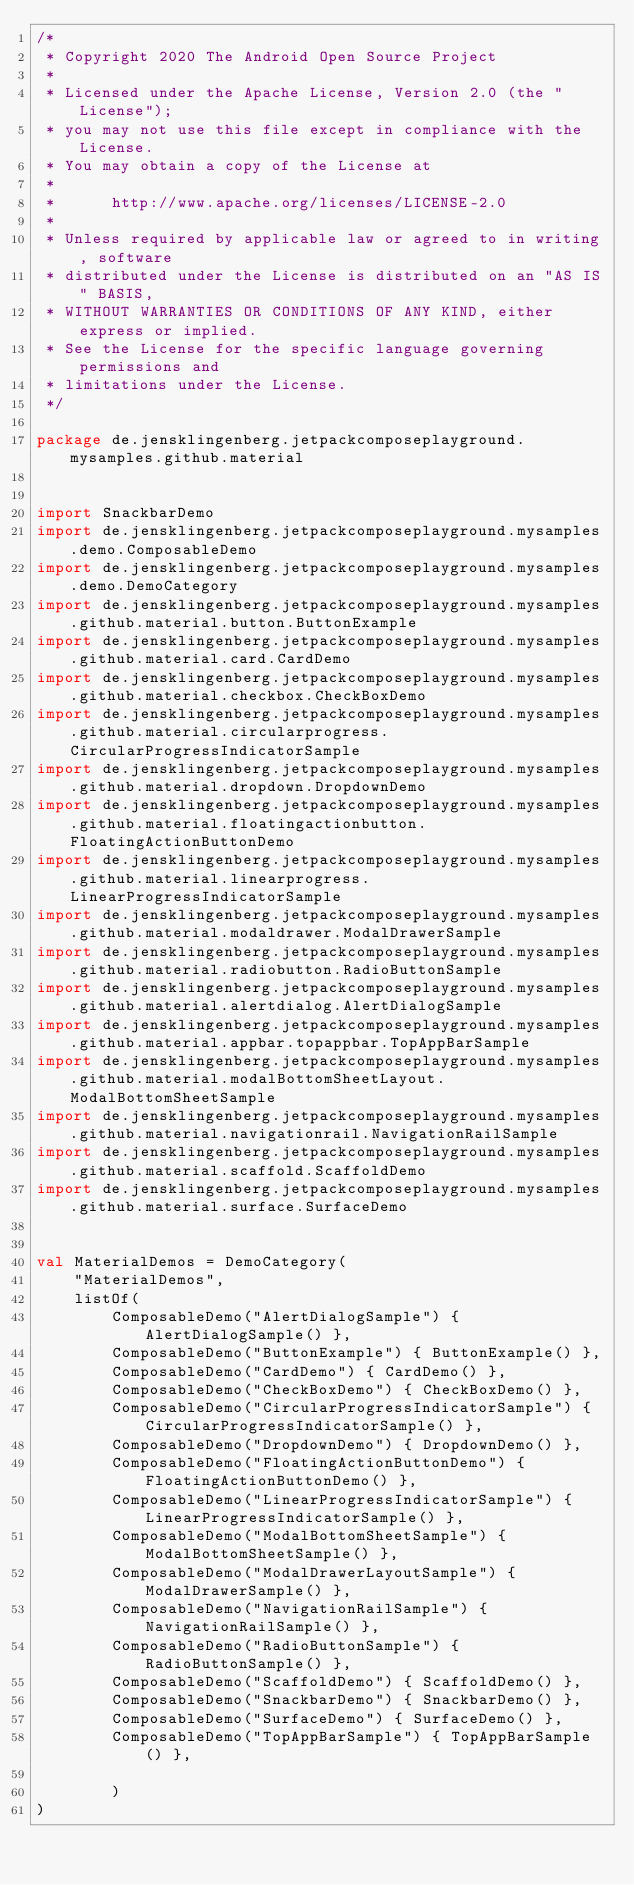<code> <loc_0><loc_0><loc_500><loc_500><_Kotlin_>/*
 * Copyright 2020 The Android Open Source Project
 *
 * Licensed under the Apache License, Version 2.0 (the "License");
 * you may not use this file except in compliance with the License.
 * You may obtain a copy of the License at
 *
 *      http://www.apache.org/licenses/LICENSE-2.0
 *
 * Unless required by applicable law or agreed to in writing, software
 * distributed under the License is distributed on an "AS IS" BASIS,
 * WITHOUT WARRANTIES OR CONDITIONS OF ANY KIND, either express or implied.
 * See the License for the specific language governing permissions and
 * limitations under the License.
 */

package de.jensklingenberg.jetpackcomposeplayground.mysamples.github.material


import SnackbarDemo
import de.jensklingenberg.jetpackcomposeplayground.mysamples.demo.ComposableDemo
import de.jensklingenberg.jetpackcomposeplayground.mysamples.demo.DemoCategory
import de.jensklingenberg.jetpackcomposeplayground.mysamples.github.material.button.ButtonExample
import de.jensklingenberg.jetpackcomposeplayground.mysamples.github.material.card.CardDemo
import de.jensklingenberg.jetpackcomposeplayground.mysamples.github.material.checkbox.CheckBoxDemo
import de.jensklingenberg.jetpackcomposeplayground.mysamples.github.material.circularprogress.CircularProgressIndicatorSample
import de.jensklingenberg.jetpackcomposeplayground.mysamples.github.material.dropdown.DropdownDemo
import de.jensklingenberg.jetpackcomposeplayground.mysamples.github.material.floatingactionbutton.FloatingActionButtonDemo
import de.jensklingenberg.jetpackcomposeplayground.mysamples.github.material.linearprogress.LinearProgressIndicatorSample
import de.jensklingenberg.jetpackcomposeplayground.mysamples.github.material.modaldrawer.ModalDrawerSample
import de.jensklingenberg.jetpackcomposeplayground.mysamples.github.material.radiobutton.RadioButtonSample
import de.jensklingenberg.jetpackcomposeplayground.mysamples.github.material.alertdialog.AlertDialogSample
import de.jensklingenberg.jetpackcomposeplayground.mysamples.github.material.appbar.topappbar.TopAppBarSample
import de.jensklingenberg.jetpackcomposeplayground.mysamples.github.material.modalBottomSheetLayout.ModalBottomSheetSample
import de.jensklingenberg.jetpackcomposeplayground.mysamples.github.material.navigationrail.NavigationRailSample
import de.jensklingenberg.jetpackcomposeplayground.mysamples.github.material.scaffold.ScaffoldDemo
import de.jensklingenberg.jetpackcomposeplayground.mysamples.github.material.surface.SurfaceDemo


val MaterialDemos = DemoCategory(
    "MaterialDemos",
    listOf(
        ComposableDemo("AlertDialogSample") { AlertDialogSample() },
        ComposableDemo("ButtonExample") { ButtonExample() },
        ComposableDemo("CardDemo") { CardDemo() },
        ComposableDemo("CheckBoxDemo") { CheckBoxDemo() },
        ComposableDemo("CircularProgressIndicatorSample") { CircularProgressIndicatorSample() },
        ComposableDemo("DropdownDemo") { DropdownDemo() },
        ComposableDemo("FloatingActionButtonDemo") { FloatingActionButtonDemo() },
        ComposableDemo("LinearProgressIndicatorSample") { LinearProgressIndicatorSample() },
        ComposableDemo("ModalBottomSheetSample") { ModalBottomSheetSample() },
        ComposableDemo("ModalDrawerLayoutSample") { ModalDrawerSample() },
        ComposableDemo("NavigationRailSample") { NavigationRailSample() },
        ComposableDemo("RadioButtonSample") { RadioButtonSample() },
        ComposableDemo("ScaffoldDemo") { ScaffoldDemo() },
        ComposableDemo("SnackbarDemo") { SnackbarDemo() },
        ComposableDemo("SurfaceDemo") { SurfaceDemo() },
        ComposableDemo("TopAppBarSample") { TopAppBarSample() },

        )
)
</code> 